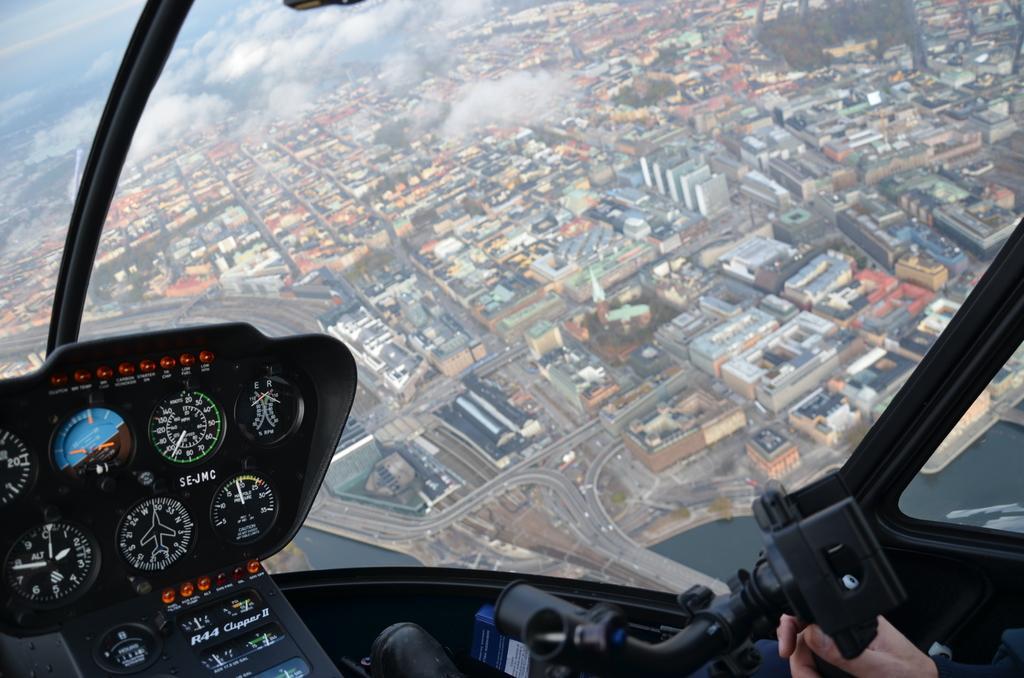Describe this image in one or two sentences. In the foreground of the image we can see an inside view of a vehicle with some dials, switches and a person. In the background, we can see a group of buildings, water, pathways and the sky. 